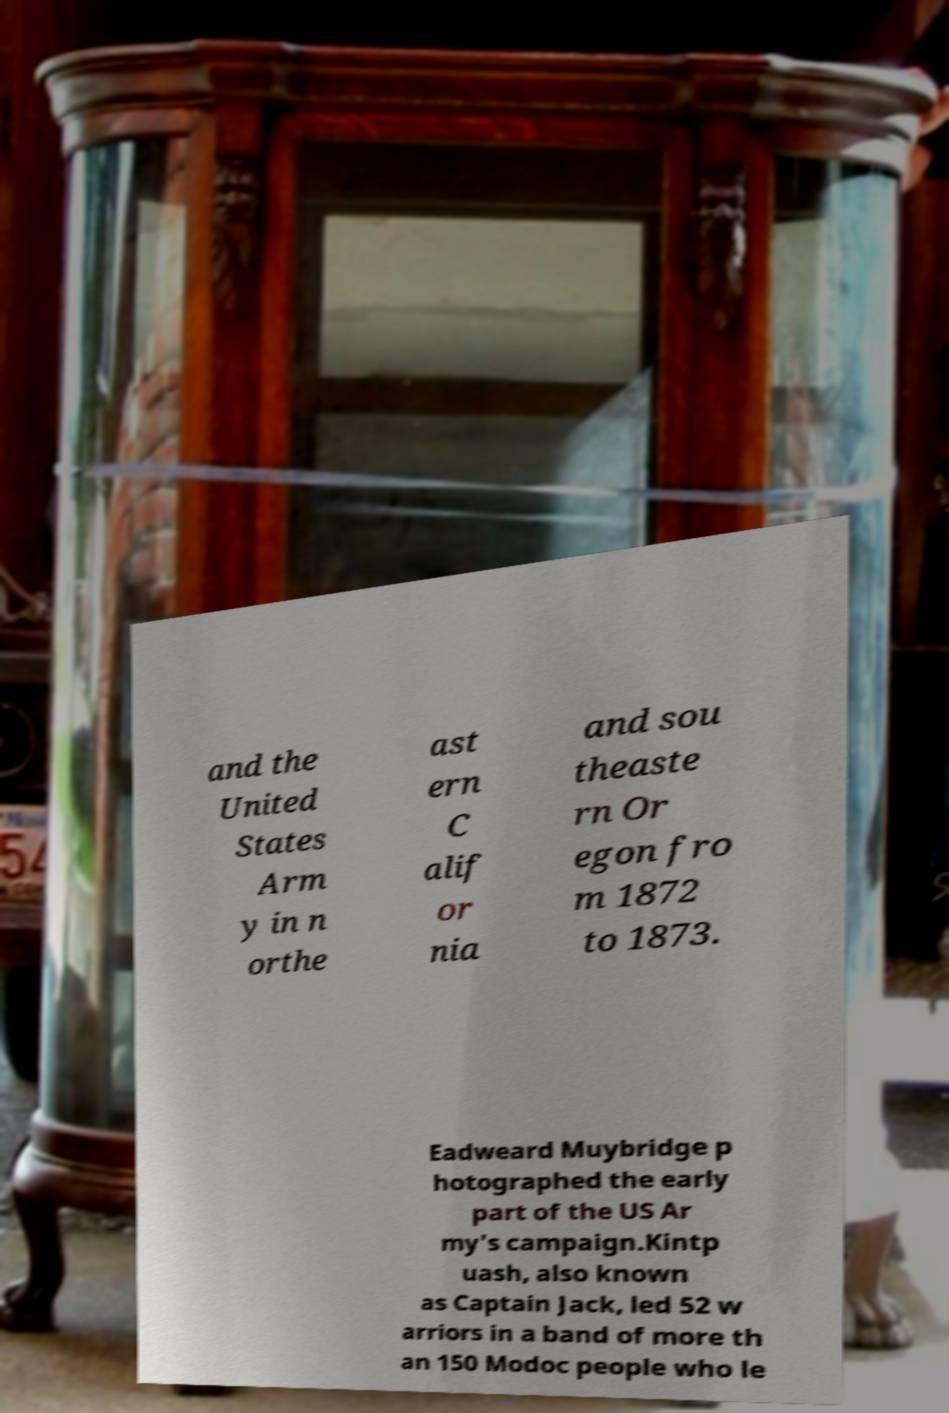Please read and relay the text visible in this image. What does it say? and the United States Arm y in n orthe ast ern C alif or nia and sou theaste rn Or egon fro m 1872 to 1873. Eadweard Muybridge p hotographed the early part of the US Ar my's campaign.Kintp uash, also known as Captain Jack, led 52 w arriors in a band of more th an 150 Modoc people who le 